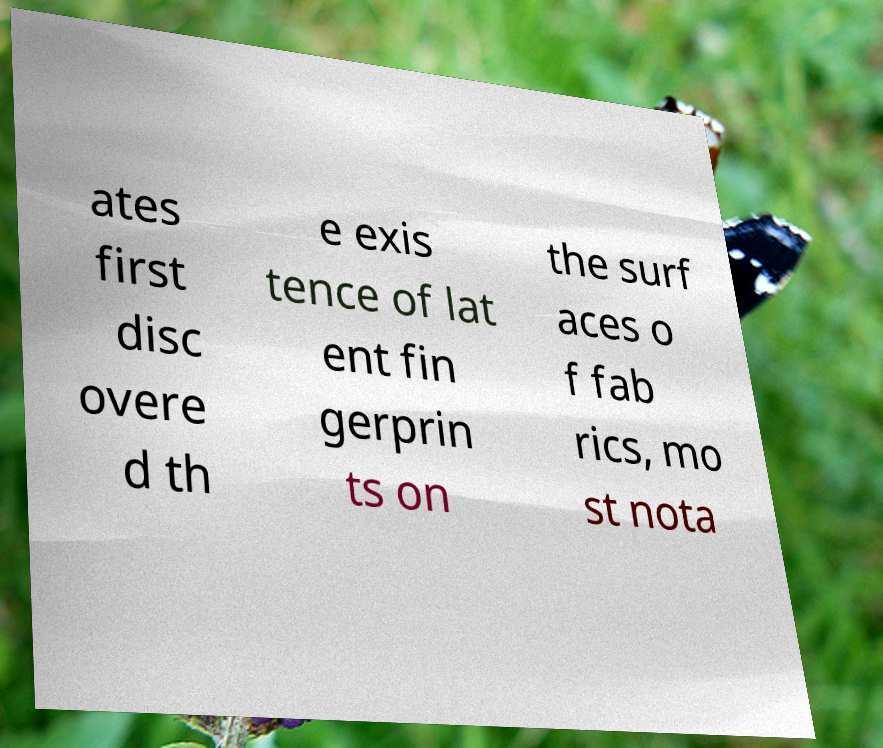Can you read and provide the text displayed in the image?This photo seems to have some interesting text. Can you extract and type it out for me? ates first disc overe d th e exis tence of lat ent fin gerprin ts on the surf aces o f fab rics, mo st nota 